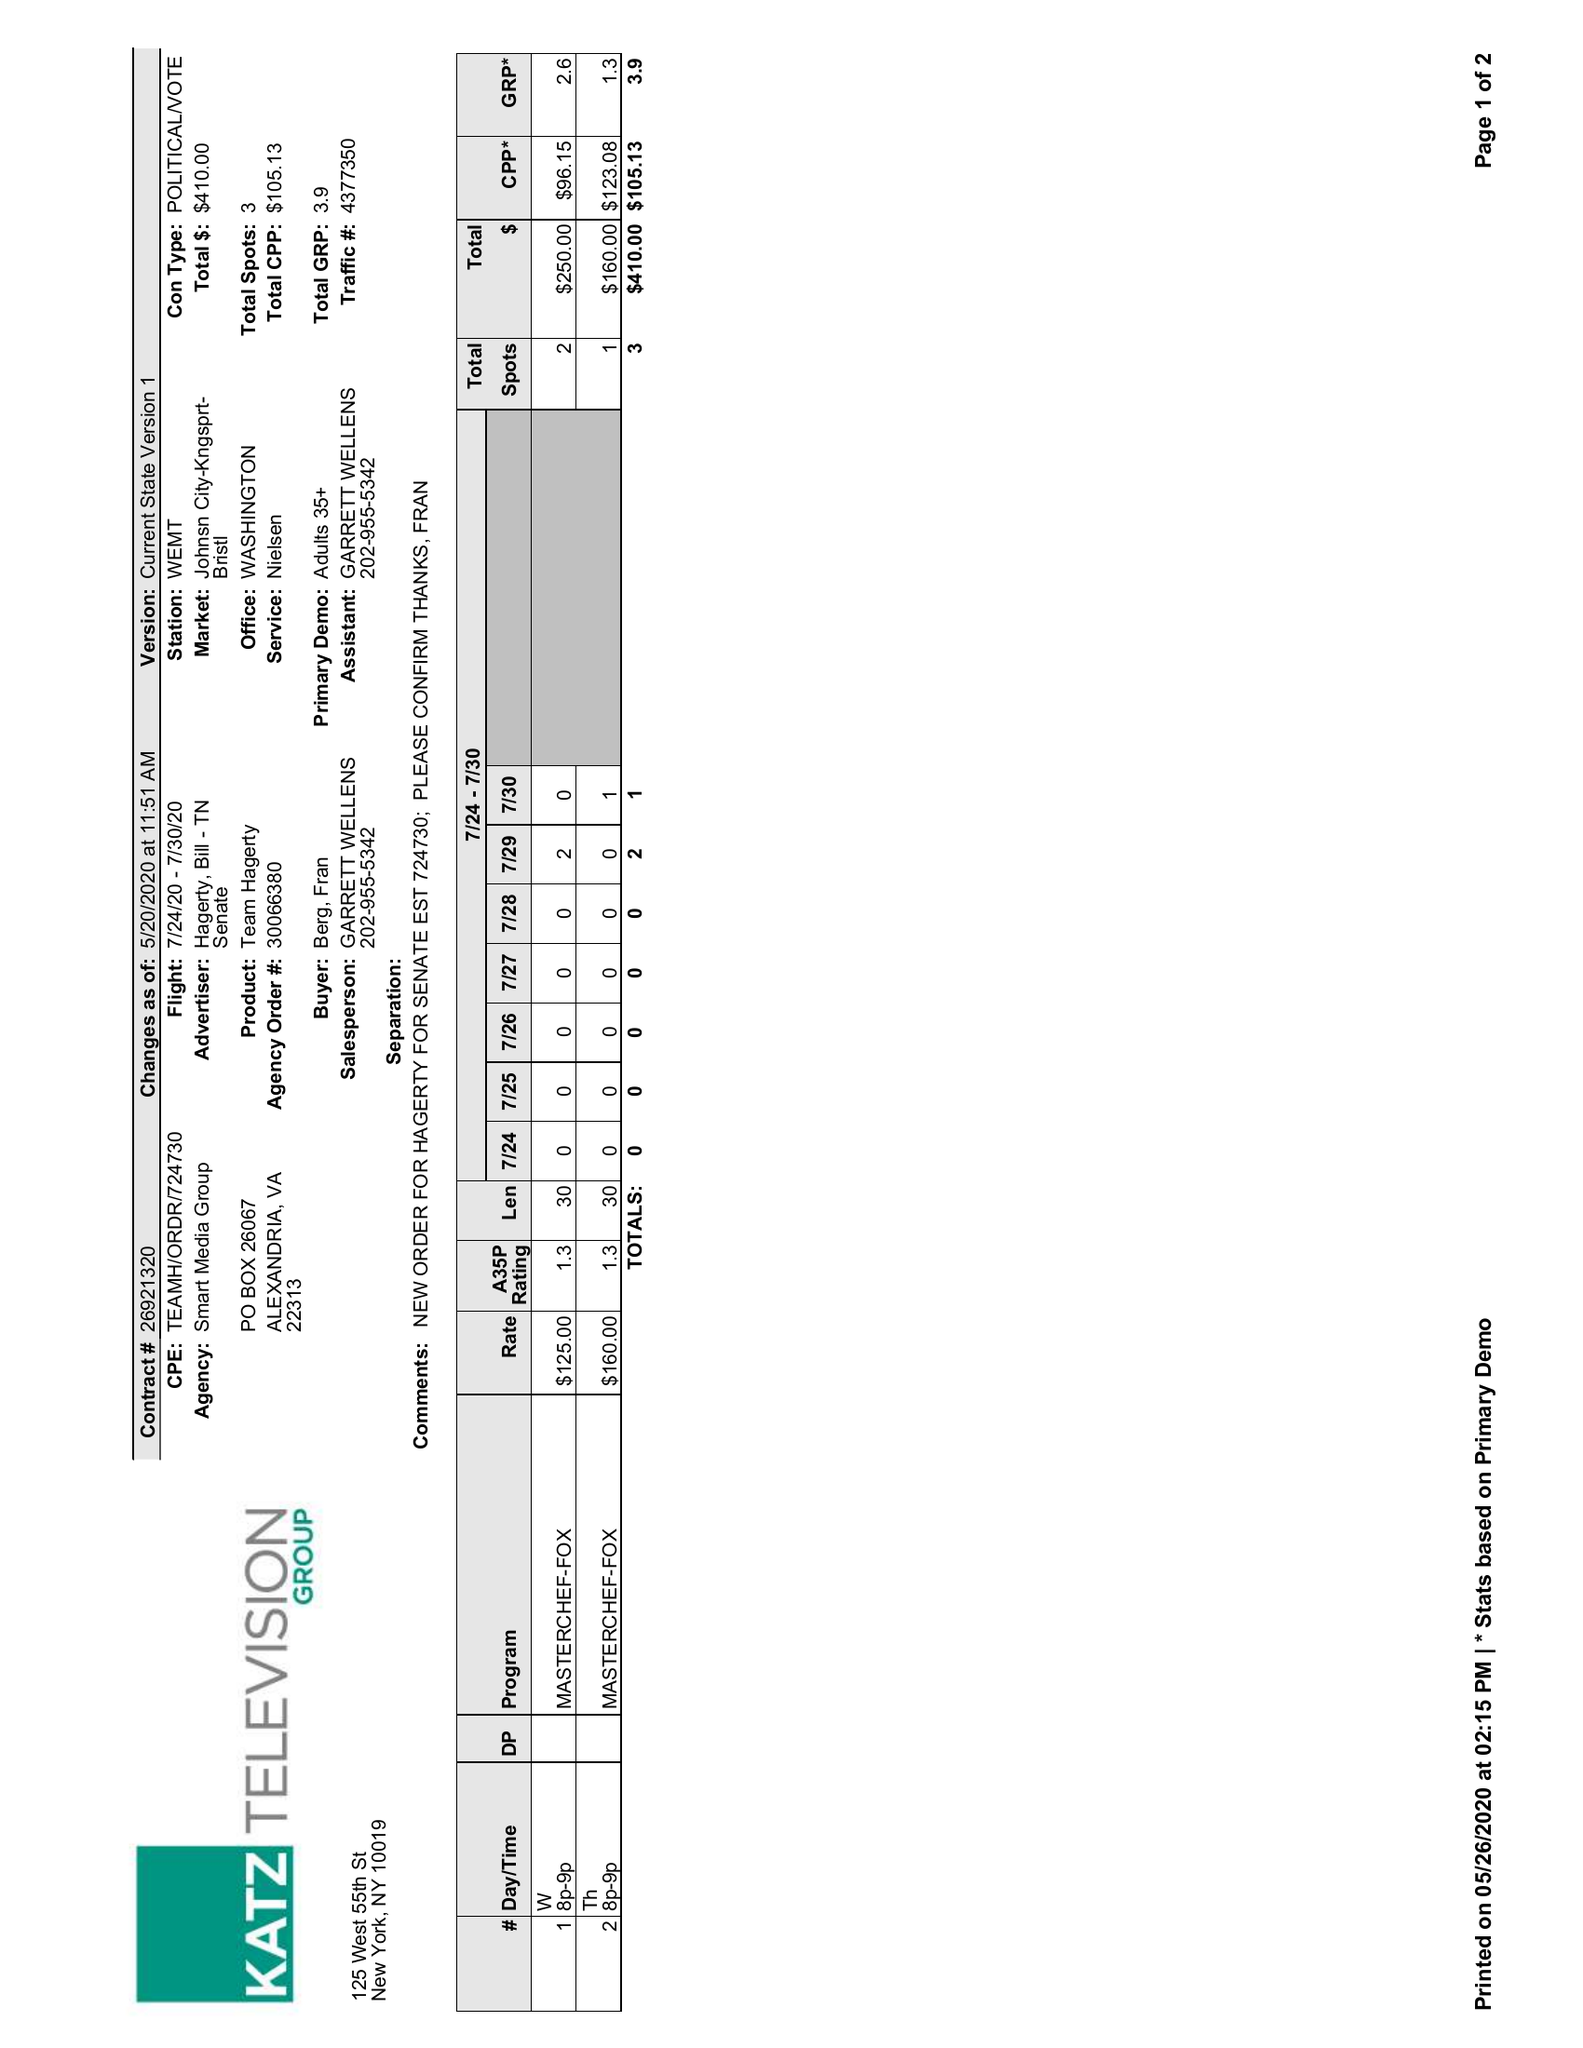What is the value for the flight_from?
Answer the question using a single word or phrase. 07/24/20 